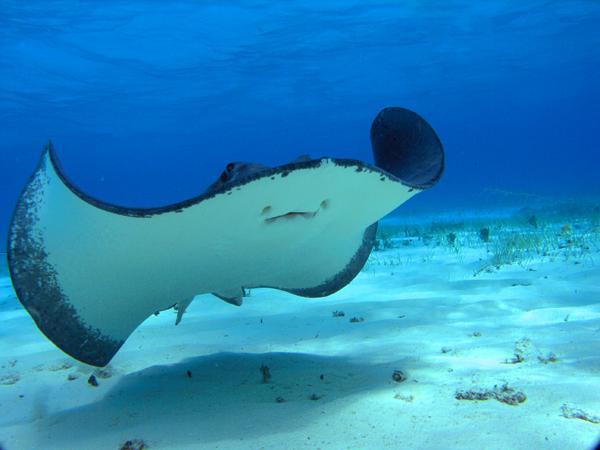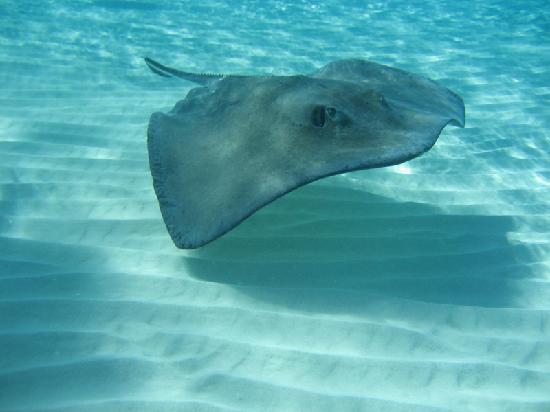The first image is the image on the left, the second image is the image on the right. Assess this claim about the two images: "There is at least one person snorkeling in the water near one or more sting rays". Correct or not? Answer yes or no. No. The first image is the image on the left, the second image is the image on the right. Given the left and right images, does the statement "There is one human in the left image." hold true? Answer yes or no. No. 